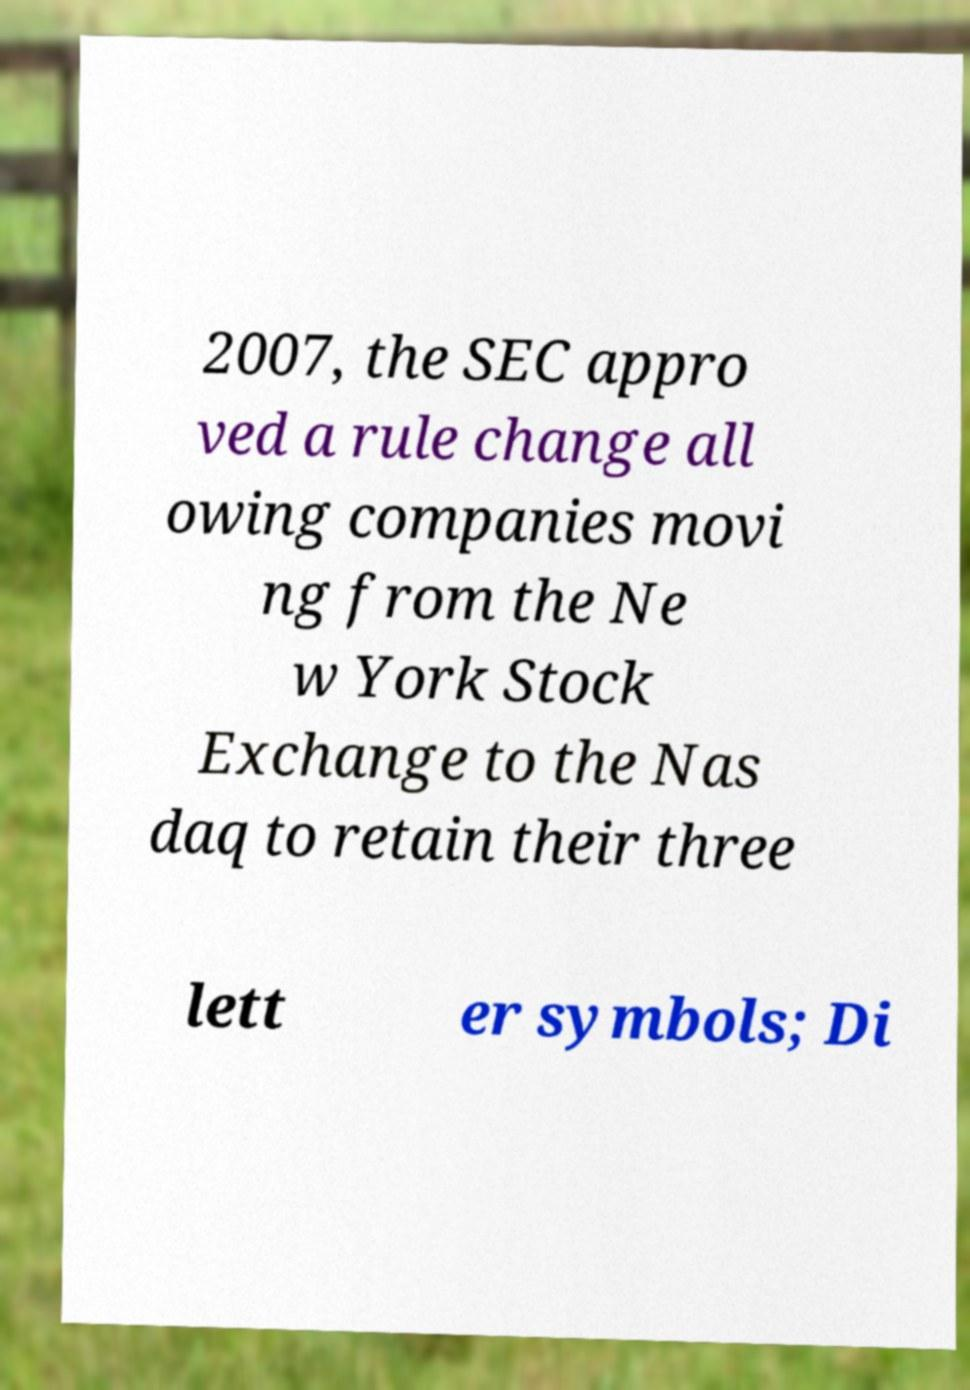Can you read and provide the text displayed in the image?This photo seems to have some interesting text. Can you extract and type it out for me? 2007, the SEC appro ved a rule change all owing companies movi ng from the Ne w York Stock Exchange to the Nas daq to retain their three lett er symbols; Di 